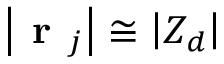Convert formula to latex. <formula><loc_0><loc_0><loc_500><loc_500>\left | r _ { j } \right | \cong \left | Z _ { d } \right |</formula> 